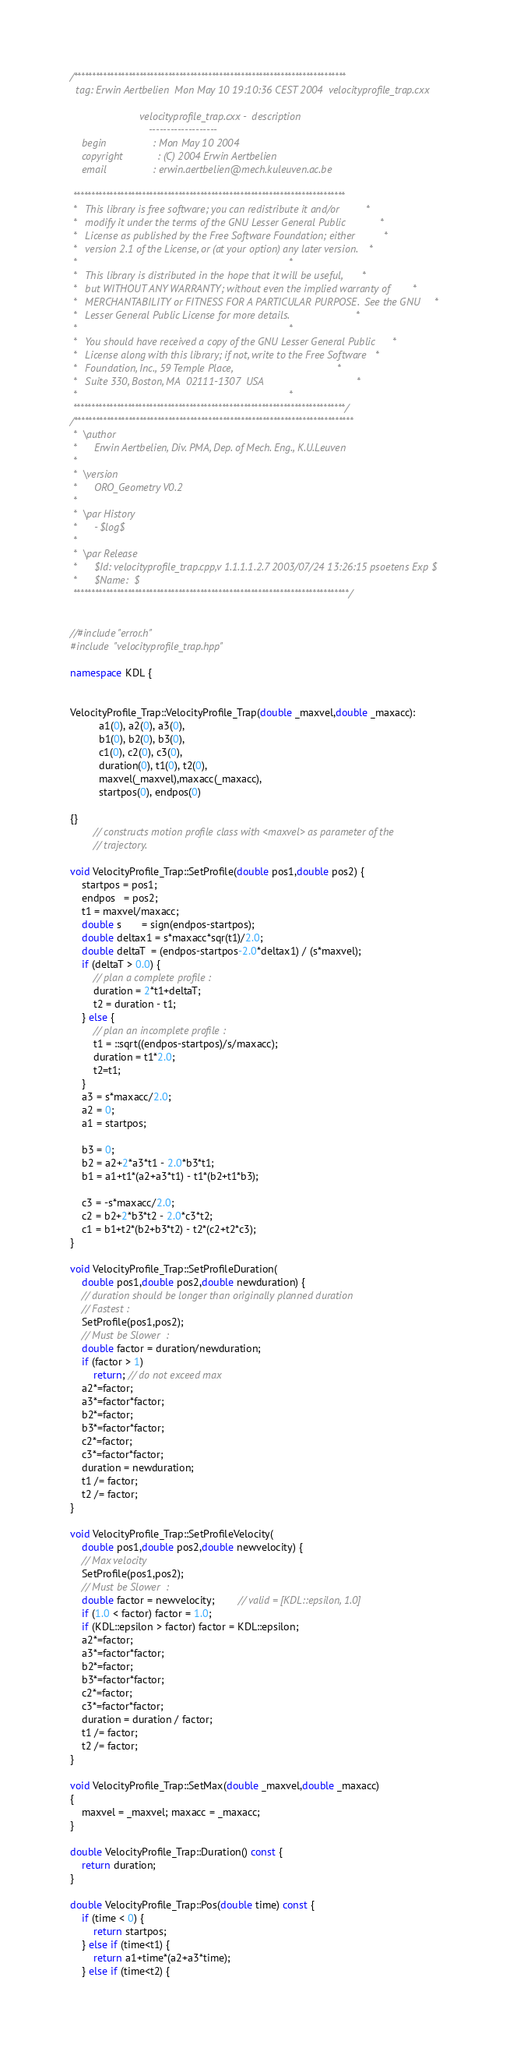Convert code to text. <code><loc_0><loc_0><loc_500><loc_500><_C++_>/***************************************************************************
  tag: Erwin Aertbelien  Mon May 10 19:10:36 CEST 2004  velocityprofile_trap.cxx

                        velocityprofile_trap.cxx -  description
                           -------------------
    begin                : Mon May 10 2004
    copyright            : (C) 2004 Erwin Aertbelien
    email                : erwin.aertbelien@mech.kuleuven.ac.be

 ***************************************************************************
 *   This library is free software; you can redistribute it and/or         *
 *   modify it under the terms of the GNU Lesser General Public            *
 *   License as published by the Free Software Foundation; either          *
 *   version 2.1 of the License, or (at your option) any later version.    *
 *                                                                         *
 *   This library is distributed in the hope that it will be useful,       *
 *   but WITHOUT ANY WARRANTY; without even the implied warranty of        *
 *   MERCHANTABILITY or FITNESS FOR A PARTICULAR PURPOSE.  See the GNU     *
 *   Lesser General Public License for more details.                       *
 *                                                                         *
 *   You should have received a copy of the GNU Lesser General Public      *
 *   License along with this library; if not, write to the Free Software   *
 *   Foundation, Inc., 59 Temple Place,                                    *
 *   Suite 330, Boston, MA  02111-1307  USA                                *
 *                                                                         *
 ***************************************************************************/
/*****************************************************************************
 *  \author
 *  	Erwin Aertbelien, Div. PMA, Dep. of Mech. Eng., K.U.Leuven
 *
 *  \version
 *		ORO_Geometry V0.2
 *
 *	\par History
 *		- $log$
 *
 *	\par Release
 *		$Id: velocityprofile_trap.cpp,v 1.1.1.1.2.7 2003/07/24 13:26:15 psoetens Exp $
 *		$Name:  $
 ****************************************************************************/


//#include "error.h"
#include "velocityprofile_trap.hpp"

namespace KDL {


VelocityProfile_Trap::VelocityProfile_Trap(double _maxvel,double _maxacc):
          a1(0), a2(0), a3(0),
          b1(0), b2(0), b3(0),
          c1(0), c2(0), c3(0),
          duration(0), t1(0), t2(0),
		  maxvel(_maxvel),maxacc(_maxacc),
          startpos(0), endpos(0)

{}
		// constructs motion profile class with <maxvel> as parameter of the
		// trajectory.

void VelocityProfile_Trap::SetProfile(double pos1,double pos2) {
	startpos = pos1;
	endpos   = pos2;
	t1 = maxvel/maxacc;
	double s       = sign(endpos-startpos);
	double deltax1 = s*maxacc*sqr(t1)/2.0;
	double deltaT  = (endpos-startpos-2.0*deltax1) / (s*maxvel);
	if (deltaT > 0.0) {
		// plan a complete profile :
		duration = 2*t1+deltaT;
		t2 = duration - t1;
	} else {
		// plan an incomplete profile :
		t1 = ::sqrt((endpos-startpos)/s/maxacc);
		duration = t1*2.0;
		t2=t1;
	}
	a3 = s*maxacc/2.0;
	a2 = 0;
	a1 = startpos;

	b3 = 0;
	b2 = a2+2*a3*t1 - 2.0*b3*t1;
	b1 = a1+t1*(a2+a3*t1) - t1*(b2+t1*b3);

	c3 = -s*maxacc/2.0;
	c2 = b2+2*b3*t2 - 2.0*c3*t2;
	c1 = b1+t2*(b2+b3*t2) - t2*(c2+t2*c3);
}

void VelocityProfile_Trap::SetProfileDuration(
	double pos1,double pos2,double newduration) {
	// duration should be longer than originally planned duration
    // Fastest :
	SetProfile(pos1,pos2);
    // Must be Slower  :
	double factor = duration/newduration;
    if (factor > 1)
        return; // do not exceed max
	a2*=factor;
	a3*=factor*factor;
	b2*=factor;
	b3*=factor*factor;
	c2*=factor;
	c3*=factor*factor;
	duration = newduration;
	t1 /= factor;
	t2 /= factor;
}

void VelocityProfile_Trap::SetProfileVelocity(
	double pos1,double pos2,double newvelocity) {
    // Max velocity
	SetProfile(pos1,pos2);
    // Must be Slower  :
	double factor = newvelocity;		// valid = [KDL::epsilon, 1.0]
	if (1.0 < factor) factor = 1.0;
	if (KDL::epsilon > factor) factor = KDL::epsilon;
	a2*=factor;
	a3*=factor*factor;
	b2*=factor;
	b3*=factor*factor;
	c2*=factor;
	c3*=factor*factor;
	duration = duration / factor;
	t1 /= factor;
	t2 /= factor;
}

void VelocityProfile_Trap::SetMax(double _maxvel,double _maxacc)
{
    maxvel = _maxvel; maxacc = _maxacc;
}

double VelocityProfile_Trap::Duration() const {
	return duration;
}

double VelocityProfile_Trap::Pos(double time) const {
	if (time < 0) {
		return startpos;
	} else if (time<t1) {
		return a1+time*(a2+a3*time);
	} else if (time<t2) {</code> 